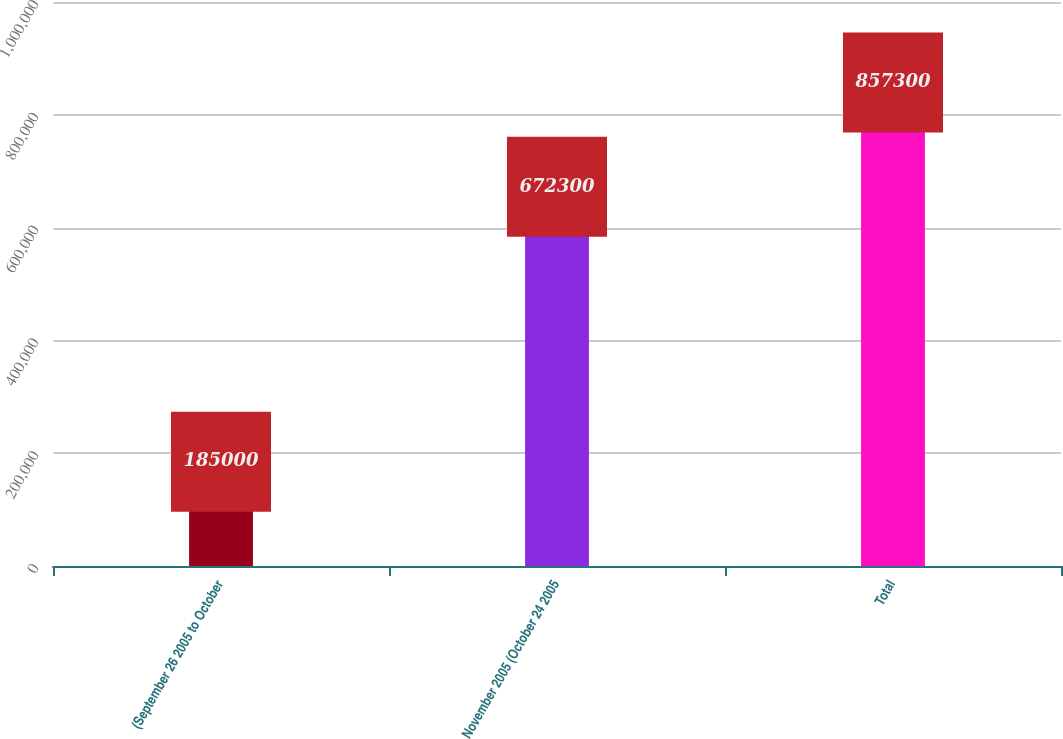Convert chart to OTSL. <chart><loc_0><loc_0><loc_500><loc_500><bar_chart><fcel>(September 26 2005 to October<fcel>November 2005 (October 24 2005<fcel>Total<nl><fcel>185000<fcel>672300<fcel>857300<nl></chart> 